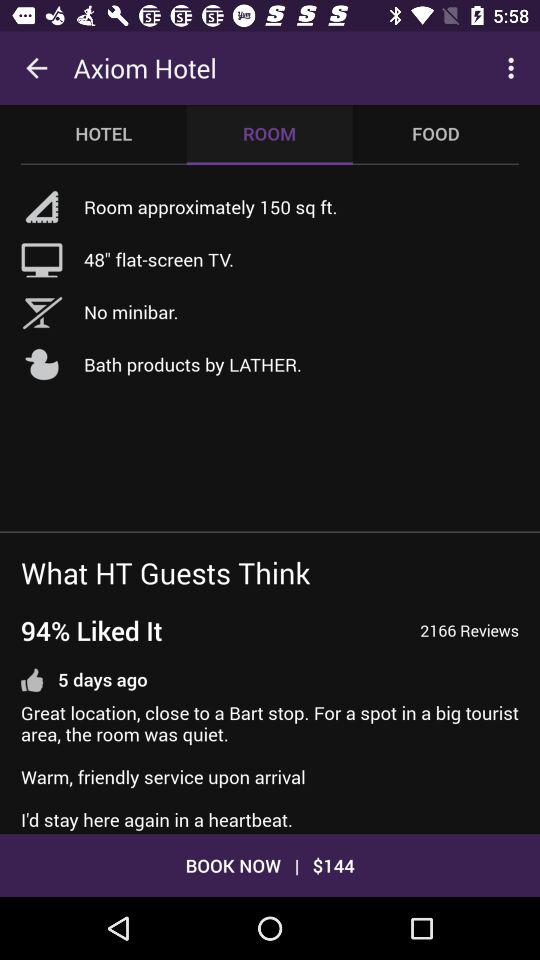Which tab is selected? The selected tab is "ROOM". 